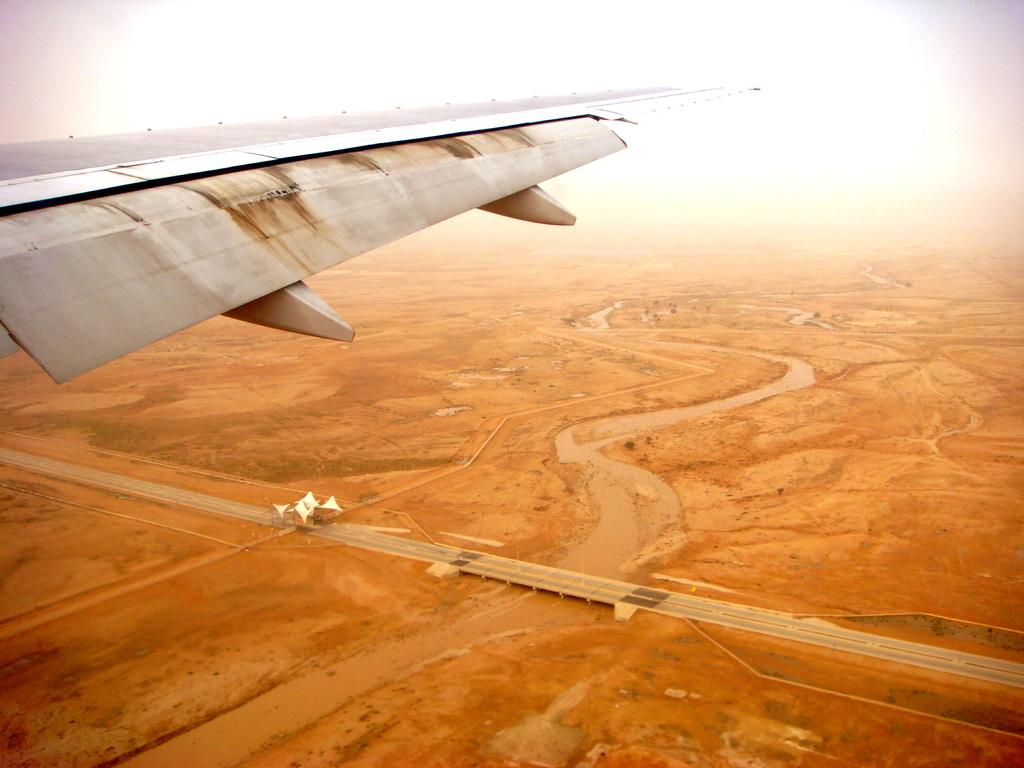What is the main subject of the image? The main subject of the image is a side wing of an aeroplane. What can be seen on the ground in the image? There is mud on the ground in the image. How much salt is visible on the side wing of the aeroplane in the image? There is no salt visible on the side wing of the aeroplane in the image. Is there a boat present in the image? No, there is no boat present in the image. 